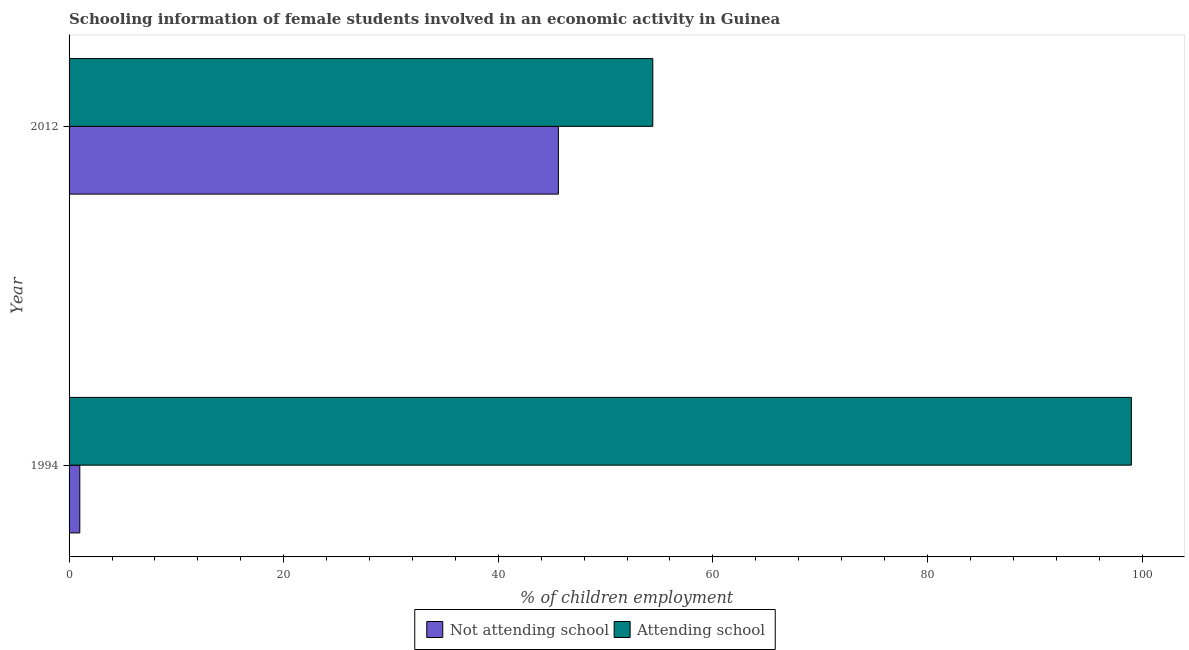Are the number of bars per tick equal to the number of legend labels?
Your answer should be very brief. Yes. What is the label of the 2nd group of bars from the top?
Keep it short and to the point. 1994. Across all years, what is the maximum percentage of employed females who are not attending school?
Ensure brevity in your answer.  45.6. Across all years, what is the minimum percentage of employed females who are attending school?
Make the answer very short. 54.4. In which year was the percentage of employed females who are attending school minimum?
Give a very brief answer. 2012. What is the total percentage of employed females who are attending school in the graph?
Offer a terse response. 153.4. What is the difference between the percentage of employed females who are not attending school in 1994 and that in 2012?
Make the answer very short. -44.6. What is the difference between the percentage of employed females who are not attending school in 2012 and the percentage of employed females who are attending school in 1994?
Your answer should be very brief. -53.4. What is the average percentage of employed females who are attending school per year?
Keep it short and to the point. 76.7. In how many years, is the percentage of employed females who are attending school greater than 44 %?
Give a very brief answer. 2. What is the ratio of the percentage of employed females who are not attending school in 1994 to that in 2012?
Your response must be concise. 0.02. In how many years, is the percentage of employed females who are attending school greater than the average percentage of employed females who are attending school taken over all years?
Give a very brief answer. 1. What does the 2nd bar from the top in 1994 represents?
Your response must be concise. Not attending school. What does the 2nd bar from the bottom in 2012 represents?
Keep it short and to the point. Attending school. How many bars are there?
Provide a short and direct response. 4. Are all the bars in the graph horizontal?
Provide a short and direct response. Yes. How many years are there in the graph?
Offer a terse response. 2. Are the values on the major ticks of X-axis written in scientific E-notation?
Make the answer very short. No. Does the graph contain any zero values?
Your response must be concise. No. Does the graph contain grids?
Your answer should be very brief. No. What is the title of the graph?
Offer a terse response. Schooling information of female students involved in an economic activity in Guinea. Does "Register a business" appear as one of the legend labels in the graph?
Make the answer very short. No. What is the label or title of the X-axis?
Offer a terse response. % of children employment. What is the label or title of the Y-axis?
Ensure brevity in your answer.  Year. What is the % of children employment of Not attending school in 1994?
Your answer should be very brief. 1. What is the % of children employment of Not attending school in 2012?
Provide a succinct answer. 45.6. What is the % of children employment in Attending school in 2012?
Offer a terse response. 54.4. Across all years, what is the maximum % of children employment of Not attending school?
Provide a short and direct response. 45.6. Across all years, what is the minimum % of children employment in Attending school?
Your answer should be very brief. 54.4. What is the total % of children employment of Not attending school in the graph?
Provide a succinct answer. 46.6. What is the total % of children employment in Attending school in the graph?
Offer a very short reply. 153.4. What is the difference between the % of children employment in Not attending school in 1994 and that in 2012?
Offer a very short reply. -44.6. What is the difference between the % of children employment in Attending school in 1994 and that in 2012?
Provide a short and direct response. 44.6. What is the difference between the % of children employment in Not attending school in 1994 and the % of children employment in Attending school in 2012?
Provide a succinct answer. -53.4. What is the average % of children employment of Not attending school per year?
Ensure brevity in your answer.  23.3. What is the average % of children employment in Attending school per year?
Give a very brief answer. 76.7. In the year 1994, what is the difference between the % of children employment in Not attending school and % of children employment in Attending school?
Keep it short and to the point. -98. In the year 2012, what is the difference between the % of children employment of Not attending school and % of children employment of Attending school?
Your response must be concise. -8.8. What is the ratio of the % of children employment in Not attending school in 1994 to that in 2012?
Your answer should be very brief. 0.02. What is the ratio of the % of children employment of Attending school in 1994 to that in 2012?
Your response must be concise. 1.82. What is the difference between the highest and the second highest % of children employment of Not attending school?
Offer a terse response. 44.6. What is the difference between the highest and the second highest % of children employment of Attending school?
Keep it short and to the point. 44.6. What is the difference between the highest and the lowest % of children employment in Not attending school?
Make the answer very short. 44.6. What is the difference between the highest and the lowest % of children employment in Attending school?
Offer a terse response. 44.6. 